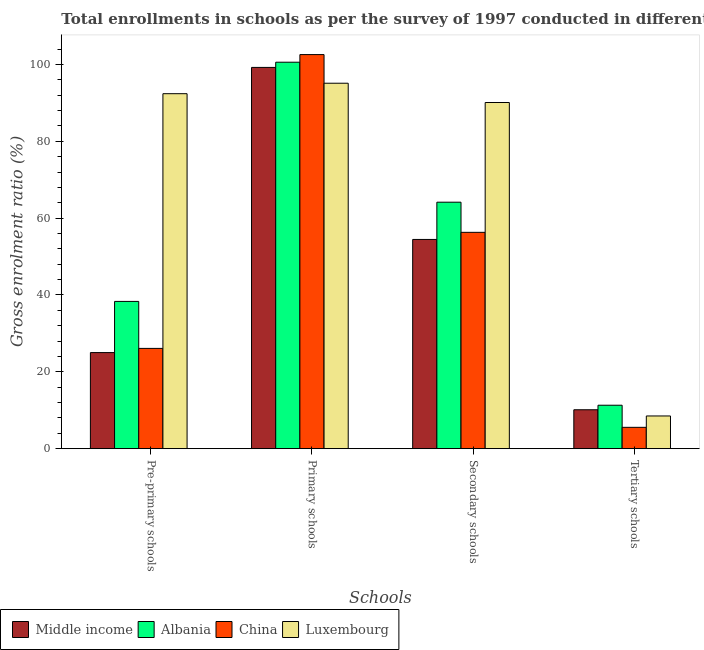How many different coloured bars are there?
Provide a succinct answer. 4. Are the number of bars per tick equal to the number of legend labels?
Provide a succinct answer. Yes. Are the number of bars on each tick of the X-axis equal?
Make the answer very short. Yes. How many bars are there on the 1st tick from the left?
Offer a very short reply. 4. What is the label of the 3rd group of bars from the left?
Ensure brevity in your answer.  Secondary schools. What is the gross enrolment ratio in tertiary schools in Luxembourg?
Offer a very short reply. 8.51. Across all countries, what is the maximum gross enrolment ratio in tertiary schools?
Your answer should be compact. 11.31. Across all countries, what is the minimum gross enrolment ratio in tertiary schools?
Make the answer very short. 5.55. In which country was the gross enrolment ratio in tertiary schools maximum?
Offer a very short reply. Albania. In which country was the gross enrolment ratio in primary schools minimum?
Make the answer very short. Luxembourg. What is the total gross enrolment ratio in tertiary schools in the graph?
Offer a very short reply. 35.5. What is the difference between the gross enrolment ratio in primary schools in Albania and that in Middle income?
Your answer should be very brief. 1.35. What is the difference between the gross enrolment ratio in tertiary schools in China and the gross enrolment ratio in primary schools in Middle income?
Your answer should be very brief. -93.67. What is the average gross enrolment ratio in secondary schools per country?
Make the answer very short. 66.25. What is the difference between the gross enrolment ratio in pre-primary schools and gross enrolment ratio in primary schools in Luxembourg?
Ensure brevity in your answer.  -2.72. In how many countries, is the gross enrolment ratio in tertiary schools greater than 40 %?
Your answer should be very brief. 0. What is the ratio of the gross enrolment ratio in pre-primary schools in China to that in Luxembourg?
Ensure brevity in your answer.  0.28. Is the gross enrolment ratio in primary schools in Middle income less than that in Luxembourg?
Keep it short and to the point. No. Is the difference between the gross enrolment ratio in primary schools in China and Middle income greater than the difference between the gross enrolment ratio in secondary schools in China and Middle income?
Your answer should be very brief. Yes. What is the difference between the highest and the second highest gross enrolment ratio in tertiary schools?
Make the answer very short. 1.18. What is the difference between the highest and the lowest gross enrolment ratio in primary schools?
Give a very brief answer. 7.45. Is it the case that in every country, the sum of the gross enrolment ratio in pre-primary schools and gross enrolment ratio in tertiary schools is greater than the sum of gross enrolment ratio in secondary schools and gross enrolment ratio in primary schools?
Provide a succinct answer. No. What does the 2nd bar from the left in Secondary schools represents?
Ensure brevity in your answer.  Albania. What does the 3rd bar from the right in Pre-primary schools represents?
Offer a terse response. Albania. Where does the legend appear in the graph?
Your response must be concise. Bottom left. What is the title of the graph?
Your answer should be very brief. Total enrollments in schools as per the survey of 1997 conducted in different countries. Does "Dominican Republic" appear as one of the legend labels in the graph?
Provide a succinct answer. No. What is the label or title of the X-axis?
Offer a very short reply. Schools. What is the label or title of the Y-axis?
Keep it short and to the point. Gross enrolment ratio (%). What is the Gross enrolment ratio (%) of Middle income in Pre-primary schools?
Offer a very short reply. 25.01. What is the Gross enrolment ratio (%) in Albania in Pre-primary schools?
Your response must be concise. 38.33. What is the Gross enrolment ratio (%) in China in Pre-primary schools?
Provide a short and direct response. 26.1. What is the Gross enrolment ratio (%) of Luxembourg in Pre-primary schools?
Offer a terse response. 92.38. What is the Gross enrolment ratio (%) in Middle income in Primary schools?
Give a very brief answer. 99.22. What is the Gross enrolment ratio (%) in Albania in Primary schools?
Offer a very short reply. 100.58. What is the Gross enrolment ratio (%) in China in Primary schools?
Make the answer very short. 102.56. What is the Gross enrolment ratio (%) of Luxembourg in Primary schools?
Make the answer very short. 95.11. What is the Gross enrolment ratio (%) in Middle income in Secondary schools?
Make the answer very short. 54.45. What is the Gross enrolment ratio (%) in Albania in Secondary schools?
Provide a short and direct response. 64.15. What is the Gross enrolment ratio (%) in China in Secondary schools?
Ensure brevity in your answer.  56.3. What is the Gross enrolment ratio (%) of Luxembourg in Secondary schools?
Your answer should be very brief. 90.09. What is the Gross enrolment ratio (%) in Middle income in Tertiary schools?
Provide a short and direct response. 10.13. What is the Gross enrolment ratio (%) in Albania in Tertiary schools?
Give a very brief answer. 11.31. What is the Gross enrolment ratio (%) in China in Tertiary schools?
Offer a terse response. 5.55. What is the Gross enrolment ratio (%) in Luxembourg in Tertiary schools?
Make the answer very short. 8.51. Across all Schools, what is the maximum Gross enrolment ratio (%) in Middle income?
Keep it short and to the point. 99.22. Across all Schools, what is the maximum Gross enrolment ratio (%) in Albania?
Give a very brief answer. 100.58. Across all Schools, what is the maximum Gross enrolment ratio (%) in China?
Give a very brief answer. 102.56. Across all Schools, what is the maximum Gross enrolment ratio (%) in Luxembourg?
Offer a terse response. 95.11. Across all Schools, what is the minimum Gross enrolment ratio (%) in Middle income?
Offer a very short reply. 10.13. Across all Schools, what is the minimum Gross enrolment ratio (%) of Albania?
Keep it short and to the point. 11.31. Across all Schools, what is the minimum Gross enrolment ratio (%) of China?
Provide a succinct answer. 5.55. Across all Schools, what is the minimum Gross enrolment ratio (%) of Luxembourg?
Give a very brief answer. 8.51. What is the total Gross enrolment ratio (%) in Middle income in the graph?
Your answer should be compact. 188.81. What is the total Gross enrolment ratio (%) of Albania in the graph?
Make the answer very short. 214.36. What is the total Gross enrolment ratio (%) of China in the graph?
Provide a short and direct response. 190.51. What is the total Gross enrolment ratio (%) in Luxembourg in the graph?
Give a very brief answer. 286.09. What is the difference between the Gross enrolment ratio (%) of Middle income in Pre-primary schools and that in Primary schools?
Provide a succinct answer. -74.22. What is the difference between the Gross enrolment ratio (%) of Albania in Pre-primary schools and that in Primary schools?
Your answer should be very brief. -62.25. What is the difference between the Gross enrolment ratio (%) in China in Pre-primary schools and that in Primary schools?
Provide a succinct answer. -76.46. What is the difference between the Gross enrolment ratio (%) in Luxembourg in Pre-primary schools and that in Primary schools?
Provide a succinct answer. -2.72. What is the difference between the Gross enrolment ratio (%) in Middle income in Pre-primary schools and that in Secondary schools?
Ensure brevity in your answer.  -29.45. What is the difference between the Gross enrolment ratio (%) of Albania in Pre-primary schools and that in Secondary schools?
Provide a succinct answer. -25.82. What is the difference between the Gross enrolment ratio (%) in China in Pre-primary schools and that in Secondary schools?
Provide a succinct answer. -30.2. What is the difference between the Gross enrolment ratio (%) of Luxembourg in Pre-primary schools and that in Secondary schools?
Your response must be concise. 2.29. What is the difference between the Gross enrolment ratio (%) of Middle income in Pre-primary schools and that in Tertiary schools?
Your response must be concise. 14.88. What is the difference between the Gross enrolment ratio (%) of Albania in Pre-primary schools and that in Tertiary schools?
Keep it short and to the point. 27.02. What is the difference between the Gross enrolment ratio (%) of China in Pre-primary schools and that in Tertiary schools?
Your response must be concise. 20.55. What is the difference between the Gross enrolment ratio (%) of Luxembourg in Pre-primary schools and that in Tertiary schools?
Provide a succinct answer. 83.87. What is the difference between the Gross enrolment ratio (%) in Middle income in Primary schools and that in Secondary schools?
Your answer should be very brief. 44.77. What is the difference between the Gross enrolment ratio (%) in Albania in Primary schools and that in Secondary schools?
Make the answer very short. 36.43. What is the difference between the Gross enrolment ratio (%) in China in Primary schools and that in Secondary schools?
Your answer should be compact. 46.26. What is the difference between the Gross enrolment ratio (%) of Luxembourg in Primary schools and that in Secondary schools?
Your response must be concise. 5.02. What is the difference between the Gross enrolment ratio (%) in Middle income in Primary schools and that in Tertiary schools?
Offer a very short reply. 89.09. What is the difference between the Gross enrolment ratio (%) of Albania in Primary schools and that in Tertiary schools?
Offer a terse response. 89.27. What is the difference between the Gross enrolment ratio (%) of China in Primary schools and that in Tertiary schools?
Provide a short and direct response. 97.01. What is the difference between the Gross enrolment ratio (%) of Luxembourg in Primary schools and that in Tertiary schools?
Your answer should be very brief. 86.59. What is the difference between the Gross enrolment ratio (%) in Middle income in Secondary schools and that in Tertiary schools?
Ensure brevity in your answer.  44.32. What is the difference between the Gross enrolment ratio (%) in Albania in Secondary schools and that in Tertiary schools?
Give a very brief answer. 52.84. What is the difference between the Gross enrolment ratio (%) in China in Secondary schools and that in Tertiary schools?
Give a very brief answer. 50.75. What is the difference between the Gross enrolment ratio (%) of Luxembourg in Secondary schools and that in Tertiary schools?
Your answer should be very brief. 81.57. What is the difference between the Gross enrolment ratio (%) in Middle income in Pre-primary schools and the Gross enrolment ratio (%) in Albania in Primary schools?
Ensure brevity in your answer.  -75.57. What is the difference between the Gross enrolment ratio (%) in Middle income in Pre-primary schools and the Gross enrolment ratio (%) in China in Primary schools?
Your response must be concise. -77.56. What is the difference between the Gross enrolment ratio (%) in Middle income in Pre-primary schools and the Gross enrolment ratio (%) in Luxembourg in Primary schools?
Provide a succinct answer. -70.1. What is the difference between the Gross enrolment ratio (%) in Albania in Pre-primary schools and the Gross enrolment ratio (%) in China in Primary schools?
Your answer should be very brief. -64.24. What is the difference between the Gross enrolment ratio (%) of Albania in Pre-primary schools and the Gross enrolment ratio (%) of Luxembourg in Primary schools?
Your response must be concise. -56.78. What is the difference between the Gross enrolment ratio (%) in China in Pre-primary schools and the Gross enrolment ratio (%) in Luxembourg in Primary schools?
Offer a terse response. -69.01. What is the difference between the Gross enrolment ratio (%) of Middle income in Pre-primary schools and the Gross enrolment ratio (%) of Albania in Secondary schools?
Ensure brevity in your answer.  -39.14. What is the difference between the Gross enrolment ratio (%) in Middle income in Pre-primary schools and the Gross enrolment ratio (%) in China in Secondary schools?
Your response must be concise. -31.3. What is the difference between the Gross enrolment ratio (%) in Middle income in Pre-primary schools and the Gross enrolment ratio (%) in Luxembourg in Secondary schools?
Your answer should be very brief. -65.08. What is the difference between the Gross enrolment ratio (%) in Albania in Pre-primary schools and the Gross enrolment ratio (%) in China in Secondary schools?
Provide a short and direct response. -17.98. What is the difference between the Gross enrolment ratio (%) of Albania in Pre-primary schools and the Gross enrolment ratio (%) of Luxembourg in Secondary schools?
Your answer should be very brief. -51.76. What is the difference between the Gross enrolment ratio (%) in China in Pre-primary schools and the Gross enrolment ratio (%) in Luxembourg in Secondary schools?
Keep it short and to the point. -63.99. What is the difference between the Gross enrolment ratio (%) in Middle income in Pre-primary schools and the Gross enrolment ratio (%) in Albania in Tertiary schools?
Your response must be concise. 13.7. What is the difference between the Gross enrolment ratio (%) in Middle income in Pre-primary schools and the Gross enrolment ratio (%) in China in Tertiary schools?
Your response must be concise. 19.45. What is the difference between the Gross enrolment ratio (%) in Middle income in Pre-primary schools and the Gross enrolment ratio (%) in Luxembourg in Tertiary schools?
Offer a terse response. 16.49. What is the difference between the Gross enrolment ratio (%) in Albania in Pre-primary schools and the Gross enrolment ratio (%) in China in Tertiary schools?
Your response must be concise. 32.77. What is the difference between the Gross enrolment ratio (%) in Albania in Pre-primary schools and the Gross enrolment ratio (%) in Luxembourg in Tertiary schools?
Give a very brief answer. 29.81. What is the difference between the Gross enrolment ratio (%) in China in Pre-primary schools and the Gross enrolment ratio (%) in Luxembourg in Tertiary schools?
Make the answer very short. 17.58. What is the difference between the Gross enrolment ratio (%) in Middle income in Primary schools and the Gross enrolment ratio (%) in Albania in Secondary schools?
Your answer should be compact. 35.08. What is the difference between the Gross enrolment ratio (%) in Middle income in Primary schools and the Gross enrolment ratio (%) in China in Secondary schools?
Keep it short and to the point. 42.92. What is the difference between the Gross enrolment ratio (%) in Middle income in Primary schools and the Gross enrolment ratio (%) in Luxembourg in Secondary schools?
Provide a short and direct response. 9.13. What is the difference between the Gross enrolment ratio (%) of Albania in Primary schools and the Gross enrolment ratio (%) of China in Secondary schools?
Provide a short and direct response. 44.27. What is the difference between the Gross enrolment ratio (%) in Albania in Primary schools and the Gross enrolment ratio (%) in Luxembourg in Secondary schools?
Your answer should be very brief. 10.49. What is the difference between the Gross enrolment ratio (%) of China in Primary schools and the Gross enrolment ratio (%) of Luxembourg in Secondary schools?
Offer a terse response. 12.47. What is the difference between the Gross enrolment ratio (%) in Middle income in Primary schools and the Gross enrolment ratio (%) in Albania in Tertiary schools?
Give a very brief answer. 87.91. What is the difference between the Gross enrolment ratio (%) of Middle income in Primary schools and the Gross enrolment ratio (%) of China in Tertiary schools?
Offer a terse response. 93.67. What is the difference between the Gross enrolment ratio (%) in Middle income in Primary schools and the Gross enrolment ratio (%) in Luxembourg in Tertiary schools?
Offer a very short reply. 90.71. What is the difference between the Gross enrolment ratio (%) in Albania in Primary schools and the Gross enrolment ratio (%) in China in Tertiary schools?
Provide a short and direct response. 95.03. What is the difference between the Gross enrolment ratio (%) in Albania in Primary schools and the Gross enrolment ratio (%) in Luxembourg in Tertiary schools?
Offer a terse response. 92.06. What is the difference between the Gross enrolment ratio (%) in China in Primary schools and the Gross enrolment ratio (%) in Luxembourg in Tertiary schools?
Your response must be concise. 94.05. What is the difference between the Gross enrolment ratio (%) in Middle income in Secondary schools and the Gross enrolment ratio (%) in Albania in Tertiary schools?
Make the answer very short. 43.14. What is the difference between the Gross enrolment ratio (%) in Middle income in Secondary schools and the Gross enrolment ratio (%) in China in Tertiary schools?
Make the answer very short. 48.9. What is the difference between the Gross enrolment ratio (%) of Middle income in Secondary schools and the Gross enrolment ratio (%) of Luxembourg in Tertiary schools?
Keep it short and to the point. 45.94. What is the difference between the Gross enrolment ratio (%) in Albania in Secondary schools and the Gross enrolment ratio (%) in China in Tertiary schools?
Your answer should be compact. 58.59. What is the difference between the Gross enrolment ratio (%) of Albania in Secondary schools and the Gross enrolment ratio (%) of Luxembourg in Tertiary schools?
Offer a very short reply. 55.63. What is the difference between the Gross enrolment ratio (%) of China in Secondary schools and the Gross enrolment ratio (%) of Luxembourg in Tertiary schools?
Offer a terse response. 47.79. What is the average Gross enrolment ratio (%) in Middle income per Schools?
Your answer should be compact. 47.2. What is the average Gross enrolment ratio (%) of Albania per Schools?
Your answer should be very brief. 53.59. What is the average Gross enrolment ratio (%) of China per Schools?
Provide a short and direct response. 47.63. What is the average Gross enrolment ratio (%) in Luxembourg per Schools?
Provide a succinct answer. 71.52. What is the difference between the Gross enrolment ratio (%) of Middle income and Gross enrolment ratio (%) of Albania in Pre-primary schools?
Offer a terse response. -13.32. What is the difference between the Gross enrolment ratio (%) of Middle income and Gross enrolment ratio (%) of China in Pre-primary schools?
Keep it short and to the point. -1.09. What is the difference between the Gross enrolment ratio (%) of Middle income and Gross enrolment ratio (%) of Luxembourg in Pre-primary schools?
Keep it short and to the point. -67.38. What is the difference between the Gross enrolment ratio (%) in Albania and Gross enrolment ratio (%) in China in Pre-primary schools?
Your answer should be very brief. 12.23. What is the difference between the Gross enrolment ratio (%) in Albania and Gross enrolment ratio (%) in Luxembourg in Pre-primary schools?
Your answer should be compact. -54.06. What is the difference between the Gross enrolment ratio (%) of China and Gross enrolment ratio (%) of Luxembourg in Pre-primary schools?
Ensure brevity in your answer.  -66.28. What is the difference between the Gross enrolment ratio (%) of Middle income and Gross enrolment ratio (%) of Albania in Primary schools?
Offer a very short reply. -1.35. What is the difference between the Gross enrolment ratio (%) in Middle income and Gross enrolment ratio (%) in China in Primary schools?
Give a very brief answer. -3.34. What is the difference between the Gross enrolment ratio (%) in Middle income and Gross enrolment ratio (%) in Luxembourg in Primary schools?
Your response must be concise. 4.12. What is the difference between the Gross enrolment ratio (%) of Albania and Gross enrolment ratio (%) of China in Primary schools?
Provide a short and direct response. -1.99. What is the difference between the Gross enrolment ratio (%) in Albania and Gross enrolment ratio (%) in Luxembourg in Primary schools?
Give a very brief answer. 5.47. What is the difference between the Gross enrolment ratio (%) in China and Gross enrolment ratio (%) in Luxembourg in Primary schools?
Your answer should be compact. 7.45. What is the difference between the Gross enrolment ratio (%) in Middle income and Gross enrolment ratio (%) in Albania in Secondary schools?
Offer a very short reply. -9.69. What is the difference between the Gross enrolment ratio (%) of Middle income and Gross enrolment ratio (%) of China in Secondary schools?
Make the answer very short. -1.85. What is the difference between the Gross enrolment ratio (%) of Middle income and Gross enrolment ratio (%) of Luxembourg in Secondary schools?
Keep it short and to the point. -35.64. What is the difference between the Gross enrolment ratio (%) of Albania and Gross enrolment ratio (%) of China in Secondary schools?
Provide a short and direct response. 7.84. What is the difference between the Gross enrolment ratio (%) of Albania and Gross enrolment ratio (%) of Luxembourg in Secondary schools?
Your response must be concise. -25.94. What is the difference between the Gross enrolment ratio (%) of China and Gross enrolment ratio (%) of Luxembourg in Secondary schools?
Offer a terse response. -33.79. What is the difference between the Gross enrolment ratio (%) in Middle income and Gross enrolment ratio (%) in Albania in Tertiary schools?
Keep it short and to the point. -1.18. What is the difference between the Gross enrolment ratio (%) in Middle income and Gross enrolment ratio (%) in China in Tertiary schools?
Ensure brevity in your answer.  4.58. What is the difference between the Gross enrolment ratio (%) in Middle income and Gross enrolment ratio (%) in Luxembourg in Tertiary schools?
Your response must be concise. 1.61. What is the difference between the Gross enrolment ratio (%) in Albania and Gross enrolment ratio (%) in China in Tertiary schools?
Your answer should be compact. 5.76. What is the difference between the Gross enrolment ratio (%) of Albania and Gross enrolment ratio (%) of Luxembourg in Tertiary schools?
Give a very brief answer. 2.79. What is the difference between the Gross enrolment ratio (%) of China and Gross enrolment ratio (%) of Luxembourg in Tertiary schools?
Make the answer very short. -2.96. What is the ratio of the Gross enrolment ratio (%) of Middle income in Pre-primary schools to that in Primary schools?
Provide a succinct answer. 0.25. What is the ratio of the Gross enrolment ratio (%) in Albania in Pre-primary schools to that in Primary schools?
Ensure brevity in your answer.  0.38. What is the ratio of the Gross enrolment ratio (%) of China in Pre-primary schools to that in Primary schools?
Ensure brevity in your answer.  0.25. What is the ratio of the Gross enrolment ratio (%) of Luxembourg in Pre-primary schools to that in Primary schools?
Give a very brief answer. 0.97. What is the ratio of the Gross enrolment ratio (%) in Middle income in Pre-primary schools to that in Secondary schools?
Offer a terse response. 0.46. What is the ratio of the Gross enrolment ratio (%) of Albania in Pre-primary schools to that in Secondary schools?
Offer a terse response. 0.6. What is the ratio of the Gross enrolment ratio (%) in China in Pre-primary schools to that in Secondary schools?
Ensure brevity in your answer.  0.46. What is the ratio of the Gross enrolment ratio (%) in Luxembourg in Pre-primary schools to that in Secondary schools?
Ensure brevity in your answer.  1.03. What is the ratio of the Gross enrolment ratio (%) in Middle income in Pre-primary schools to that in Tertiary schools?
Make the answer very short. 2.47. What is the ratio of the Gross enrolment ratio (%) of Albania in Pre-primary schools to that in Tertiary schools?
Provide a short and direct response. 3.39. What is the ratio of the Gross enrolment ratio (%) of China in Pre-primary schools to that in Tertiary schools?
Your answer should be very brief. 4.7. What is the ratio of the Gross enrolment ratio (%) in Luxembourg in Pre-primary schools to that in Tertiary schools?
Your answer should be very brief. 10.85. What is the ratio of the Gross enrolment ratio (%) in Middle income in Primary schools to that in Secondary schools?
Provide a short and direct response. 1.82. What is the ratio of the Gross enrolment ratio (%) of Albania in Primary schools to that in Secondary schools?
Your answer should be compact. 1.57. What is the ratio of the Gross enrolment ratio (%) in China in Primary schools to that in Secondary schools?
Your answer should be compact. 1.82. What is the ratio of the Gross enrolment ratio (%) in Luxembourg in Primary schools to that in Secondary schools?
Provide a succinct answer. 1.06. What is the ratio of the Gross enrolment ratio (%) of Middle income in Primary schools to that in Tertiary schools?
Provide a succinct answer. 9.8. What is the ratio of the Gross enrolment ratio (%) of Albania in Primary schools to that in Tertiary schools?
Give a very brief answer. 8.89. What is the ratio of the Gross enrolment ratio (%) in China in Primary schools to that in Tertiary schools?
Provide a short and direct response. 18.47. What is the ratio of the Gross enrolment ratio (%) in Luxembourg in Primary schools to that in Tertiary schools?
Keep it short and to the point. 11.17. What is the ratio of the Gross enrolment ratio (%) in Middle income in Secondary schools to that in Tertiary schools?
Your answer should be very brief. 5.38. What is the ratio of the Gross enrolment ratio (%) of Albania in Secondary schools to that in Tertiary schools?
Provide a short and direct response. 5.67. What is the ratio of the Gross enrolment ratio (%) of China in Secondary schools to that in Tertiary schools?
Give a very brief answer. 10.14. What is the ratio of the Gross enrolment ratio (%) of Luxembourg in Secondary schools to that in Tertiary schools?
Make the answer very short. 10.58. What is the difference between the highest and the second highest Gross enrolment ratio (%) in Middle income?
Ensure brevity in your answer.  44.77. What is the difference between the highest and the second highest Gross enrolment ratio (%) of Albania?
Provide a short and direct response. 36.43. What is the difference between the highest and the second highest Gross enrolment ratio (%) in China?
Provide a short and direct response. 46.26. What is the difference between the highest and the second highest Gross enrolment ratio (%) in Luxembourg?
Give a very brief answer. 2.72. What is the difference between the highest and the lowest Gross enrolment ratio (%) in Middle income?
Provide a short and direct response. 89.09. What is the difference between the highest and the lowest Gross enrolment ratio (%) in Albania?
Make the answer very short. 89.27. What is the difference between the highest and the lowest Gross enrolment ratio (%) of China?
Provide a short and direct response. 97.01. What is the difference between the highest and the lowest Gross enrolment ratio (%) in Luxembourg?
Your answer should be very brief. 86.59. 